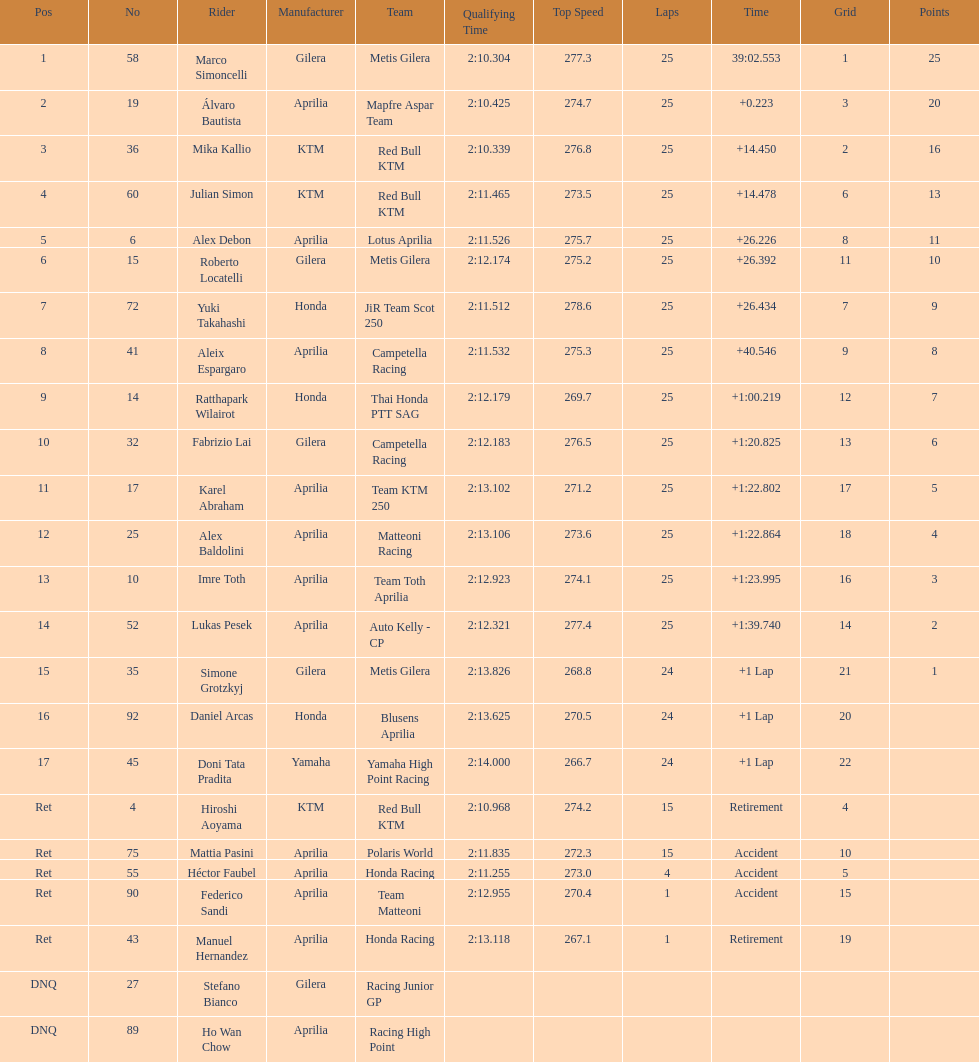Who perfomed the most number of laps, marco simoncelli or hiroshi aoyama? Marco Simoncelli. 